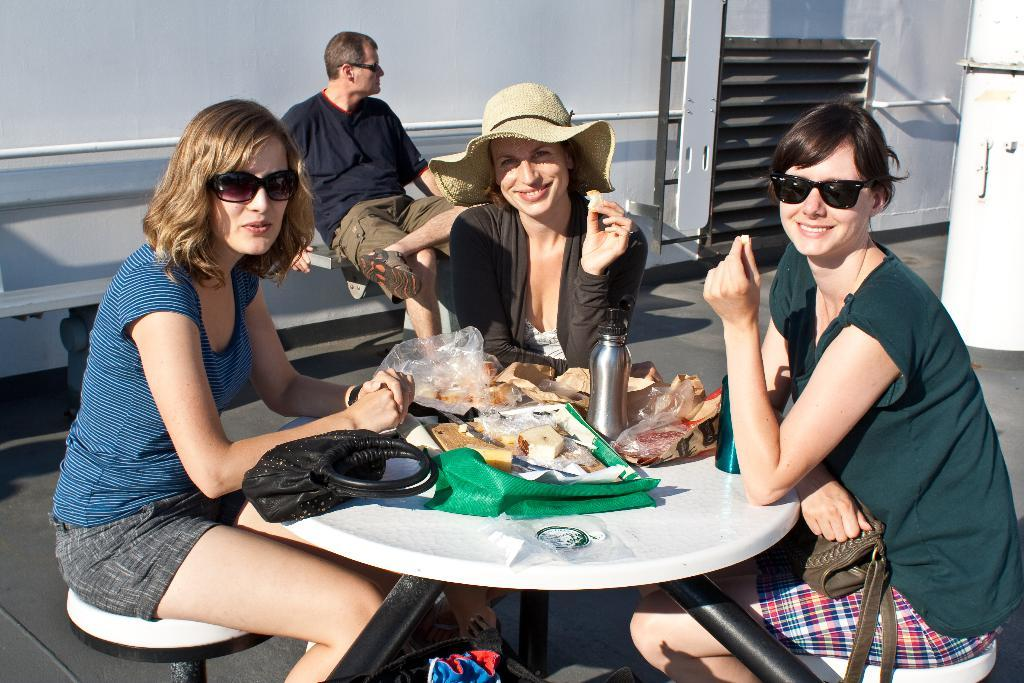What are the people in the image doing? There is a group of persons sitting on chairs. What can be seen on the table in the image? There are food items and water bottles on the table. Is there any personal belonging visible in the image? Yes, there is a bag present. How does the parcel express regret in the image? There is no parcel present in the image, and therefore no such expression of regret can be observed. 